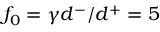Convert formula to latex. <formula><loc_0><loc_0><loc_500><loc_500>f _ { 0 } = \gamma d ^ { - } / d ^ { + } = 5</formula> 